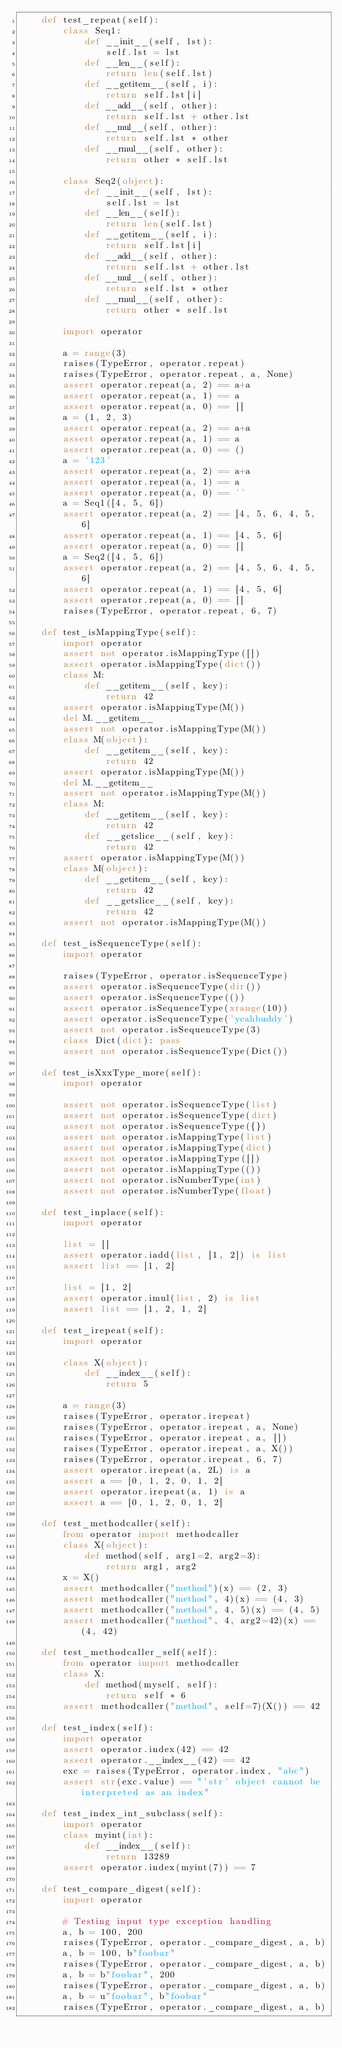<code> <loc_0><loc_0><loc_500><loc_500><_Python_>    def test_repeat(self):
        class Seq1:
            def __init__(self, lst):
                self.lst = lst
            def __len__(self):
                return len(self.lst)
            def __getitem__(self, i):
                return self.lst[i]
            def __add__(self, other):
                return self.lst + other.lst
            def __mul__(self, other):
                return self.lst * other
            def __rmul__(self, other):
                return other * self.lst

        class Seq2(object):
            def __init__(self, lst):
                self.lst = lst
            def __len__(self):
                return len(self.lst)
            def __getitem__(self, i):
                return self.lst[i]
            def __add__(self, other):
                return self.lst + other.lst
            def __mul__(self, other):
                return self.lst * other
            def __rmul__(self, other):
                return other * self.lst

        import operator

        a = range(3)
        raises(TypeError, operator.repeat)
        raises(TypeError, operator.repeat, a, None)
        assert operator.repeat(a, 2) == a+a
        assert operator.repeat(a, 1) == a
        assert operator.repeat(a, 0) == []
        a = (1, 2, 3)
        assert operator.repeat(a, 2) == a+a
        assert operator.repeat(a, 1) == a
        assert operator.repeat(a, 0) == ()
        a = '123'
        assert operator.repeat(a, 2) == a+a
        assert operator.repeat(a, 1) == a
        assert operator.repeat(a, 0) == ''
        a = Seq1([4, 5, 6])
        assert operator.repeat(a, 2) == [4, 5, 6, 4, 5, 6]
        assert operator.repeat(a, 1) == [4, 5, 6]
        assert operator.repeat(a, 0) == []
        a = Seq2([4, 5, 6])
        assert operator.repeat(a, 2) == [4, 5, 6, 4, 5, 6]
        assert operator.repeat(a, 1) == [4, 5, 6]
        assert operator.repeat(a, 0) == []
        raises(TypeError, operator.repeat, 6, 7)

    def test_isMappingType(self):
        import operator
        assert not operator.isMappingType([])
        assert operator.isMappingType(dict())
        class M:
            def __getitem__(self, key):
                return 42
        assert operator.isMappingType(M())
        del M.__getitem__
        assert not operator.isMappingType(M())
        class M(object):
            def __getitem__(self, key):
                return 42
        assert operator.isMappingType(M())
        del M.__getitem__
        assert not operator.isMappingType(M())
        class M:
            def __getitem__(self, key):
                return 42
            def __getslice__(self, key):
                return 42
        assert operator.isMappingType(M())
        class M(object):
            def __getitem__(self, key):
                return 42
            def __getslice__(self, key):
                return 42
        assert not operator.isMappingType(M())

    def test_isSequenceType(self):
        import operator

        raises(TypeError, operator.isSequenceType)
        assert operator.isSequenceType(dir())
        assert operator.isSequenceType(())
        assert operator.isSequenceType(xrange(10))
        assert operator.isSequenceType('yeahbuddy')
        assert not operator.isSequenceType(3)
        class Dict(dict): pass
        assert not operator.isSequenceType(Dict())

    def test_isXxxType_more(self):
        import operator

        assert not operator.isSequenceType(list)
        assert not operator.isSequenceType(dict)
        assert not operator.isSequenceType({})
        assert not operator.isMappingType(list)
        assert not operator.isMappingType(dict)
        assert not operator.isMappingType([])
        assert not operator.isMappingType(())
        assert not operator.isNumberType(int)
        assert not operator.isNumberType(float)

    def test_inplace(self):
        import operator

        list = []
        assert operator.iadd(list, [1, 2]) is list
        assert list == [1, 2]

        list = [1, 2]
        assert operator.imul(list, 2) is list
        assert list == [1, 2, 1, 2]

    def test_irepeat(self):
        import operator

        class X(object):
            def __index__(self):
                return 5

        a = range(3)
        raises(TypeError, operator.irepeat)
        raises(TypeError, operator.irepeat, a, None)
        raises(TypeError, operator.irepeat, a, [])
        raises(TypeError, operator.irepeat, a, X())
        raises(TypeError, operator.irepeat, 6, 7)
        assert operator.irepeat(a, 2L) is a
        assert a == [0, 1, 2, 0, 1, 2]
        assert operator.irepeat(a, 1) is a
        assert a == [0, 1, 2, 0, 1, 2]

    def test_methodcaller(self):
        from operator import methodcaller
        class X(object):
            def method(self, arg1=2, arg2=3):
                return arg1, arg2
        x = X()
        assert methodcaller("method")(x) == (2, 3)
        assert methodcaller("method", 4)(x) == (4, 3)
        assert methodcaller("method", 4, 5)(x) == (4, 5)
        assert methodcaller("method", 4, arg2=42)(x) == (4, 42)

    def test_methodcaller_self(self):
        from operator import methodcaller
        class X:
            def method(myself, self):
                return self * 6
        assert methodcaller("method", self=7)(X()) == 42

    def test_index(self):
        import operator
        assert operator.index(42) == 42
        assert operator.__index__(42) == 42
        exc = raises(TypeError, operator.index, "abc")
        assert str(exc.value) == "'str' object cannot be interpreted as an index"

    def test_index_int_subclass(self):
        import operator
        class myint(int):
            def __index__(self):
                return 13289
        assert operator.index(myint(7)) == 7

    def test_compare_digest(self):
        import operator

        # Testing input type exception handling
        a, b = 100, 200
        raises(TypeError, operator._compare_digest, a, b)
        a, b = 100, b"foobar"
        raises(TypeError, operator._compare_digest, a, b)
        a, b = b"foobar", 200
        raises(TypeError, operator._compare_digest, a, b)
        a, b = u"foobar", b"foobar"
        raises(TypeError, operator._compare_digest, a, b)</code> 